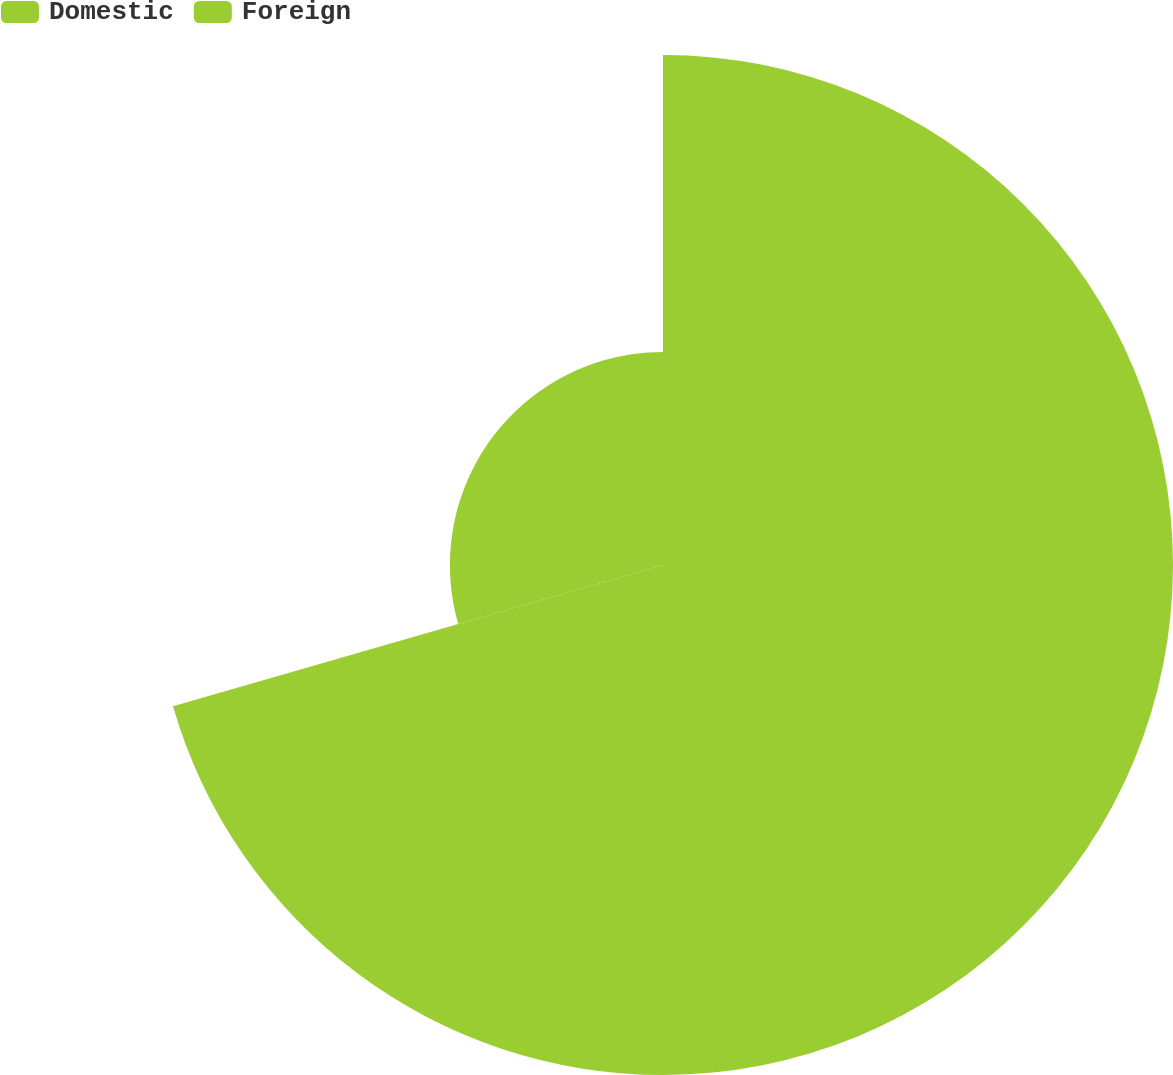Convert chart. <chart><loc_0><loc_0><loc_500><loc_500><pie_chart><fcel>Domestic<fcel>Foreign<nl><fcel>70.53%<fcel>29.47%<nl></chart> 